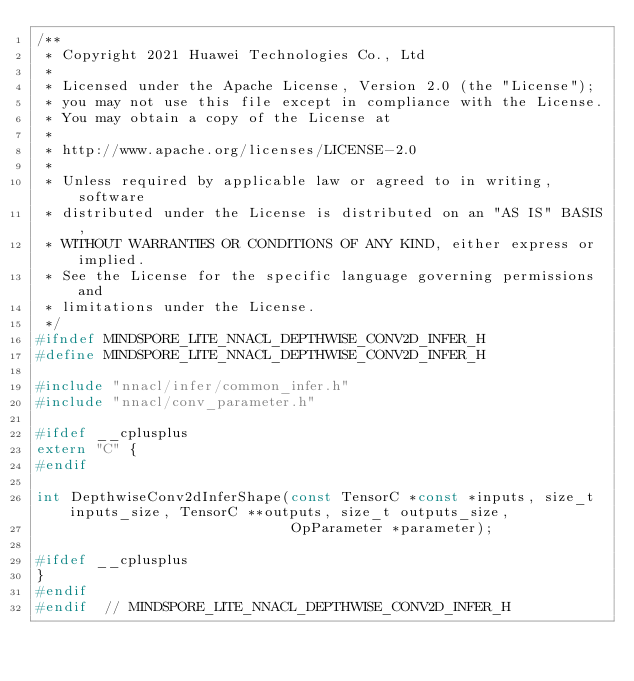Convert code to text. <code><loc_0><loc_0><loc_500><loc_500><_C_>/**
 * Copyright 2021 Huawei Technologies Co., Ltd
 *
 * Licensed under the Apache License, Version 2.0 (the "License");
 * you may not use this file except in compliance with the License.
 * You may obtain a copy of the License at
 *
 * http://www.apache.org/licenses/LICENSE-2.0
 *
 * Unless required by applicable law or agreed to in writing, software
 * distributed under the License is distributed on an "AS IS" BASIS,
 * WITHOUT WARRANTIES OR CONDITIONS OF ANY KIND, either express or implied.
 * See the License for the specific language governing permissions and
 * limitations under the License.
 */
#ifndef MINDSPORE_LITE_NNACL_DEPTHWISE_CONV2D_INFER_H
#define MINDSPORE_LITE_NNACL_DEPTHWISE_CONV2D_INFER_H

#include "nnacl/infer/common_infer.h"
#include "nnacl/conv_parameter.h"

#ifdef __cplusplus
extern "C" {
#endif

int DepthwiseConv2dInferShape(const TensorC *const *inputs, size_t inputs_size, TensorC **outputs, size_t outputs_size,
                              OpParameter *parameter);

#ifdef __cplusplus
}
#endif
#endif  // MINDSPORE_LITE_NNACL_DEPTHWISE_CONV2D_INFER_H
</code> 